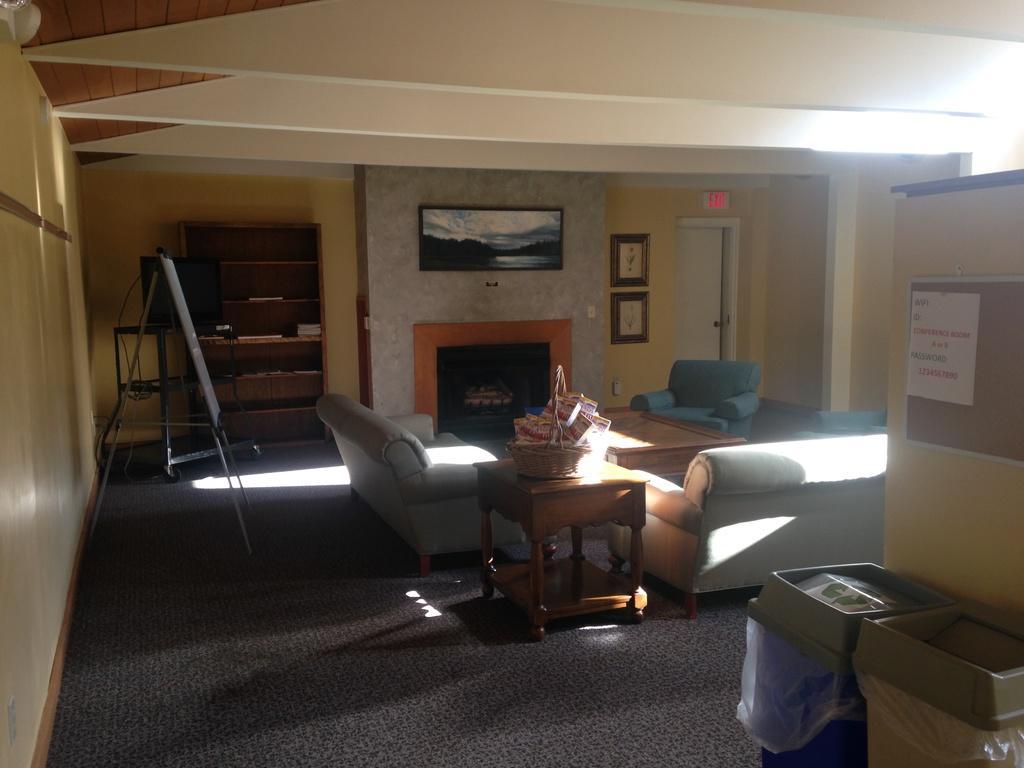Can you describe this image briefly? In this picture we can see a room with sofas, table basket on it, board with stand, door, frames to wall, screen, poster, bins, cupboard. 